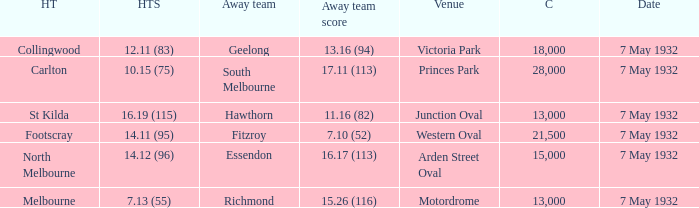What is the home team for victoria park? Collingwood. 